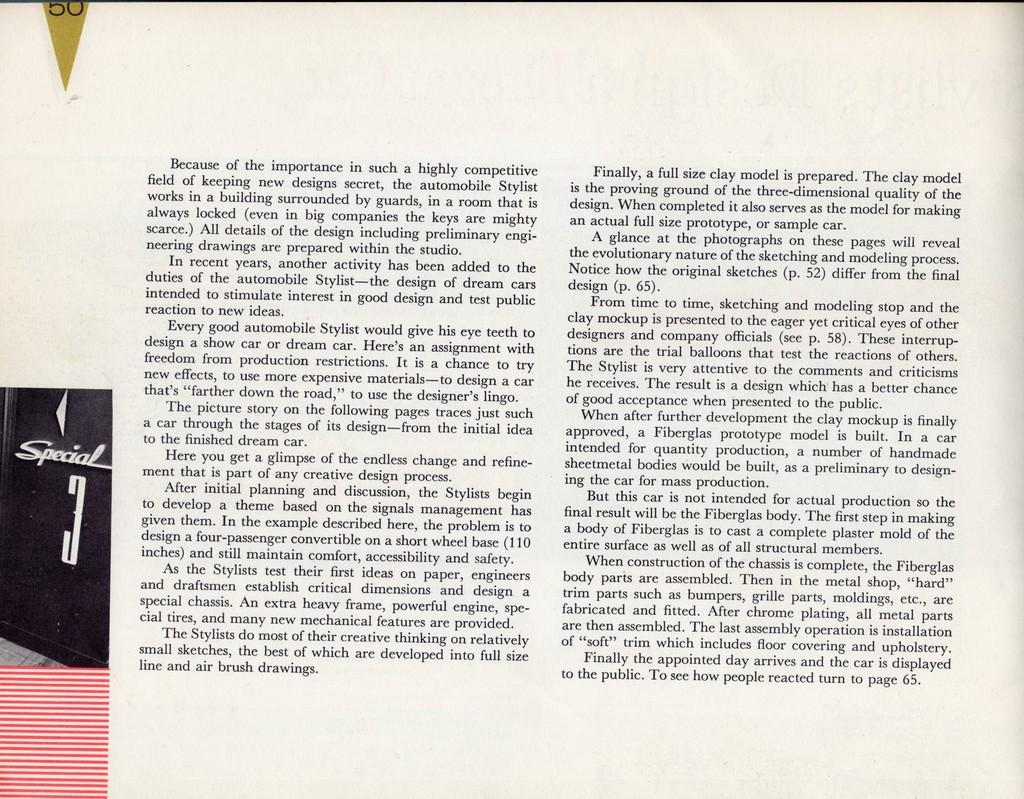Provide a one-sentence caption for the provided image. A book is open to a page describing what an automobile Stylist does. 